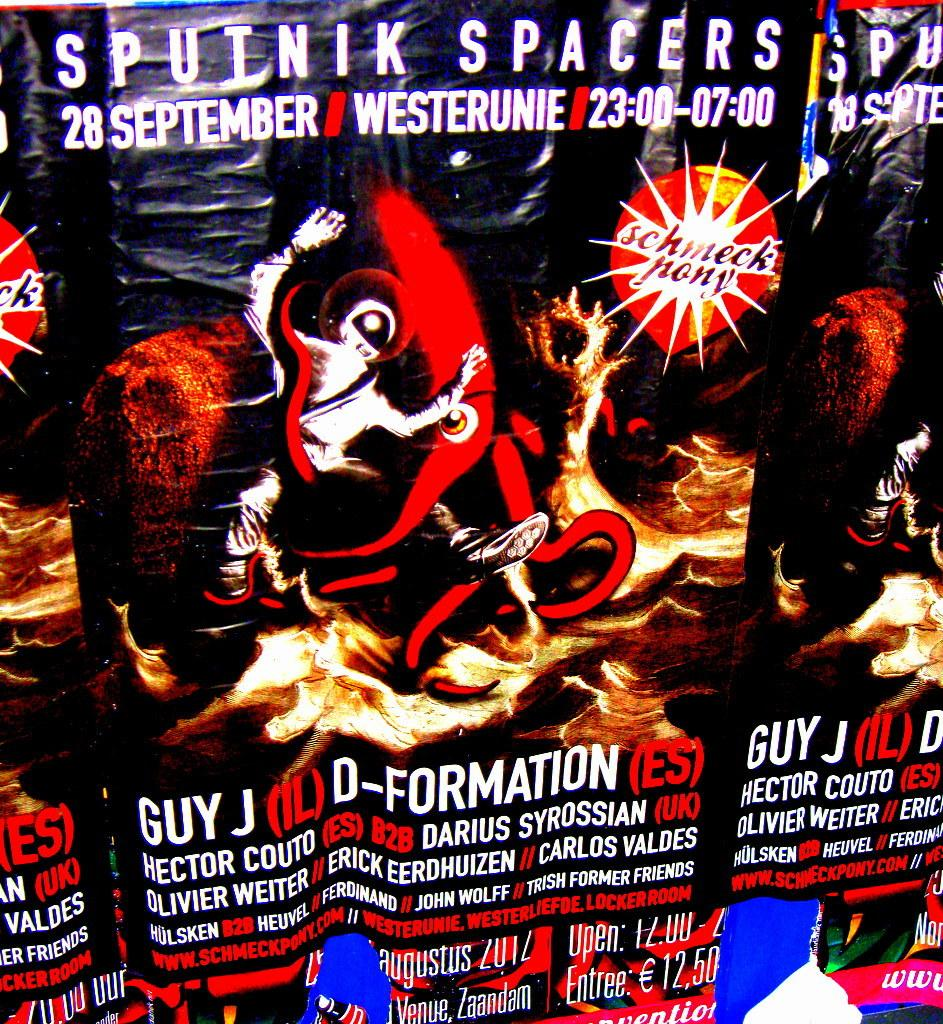<image>
Render a clear and concise summary of the photo. a sputnik spacers ad with info on it 